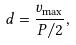Convert formula to latex. <formula><loc_0><loc_0><loc_500><loc_500>d = \frac { v _ { \max } } { P / 2 } ,</formula> 